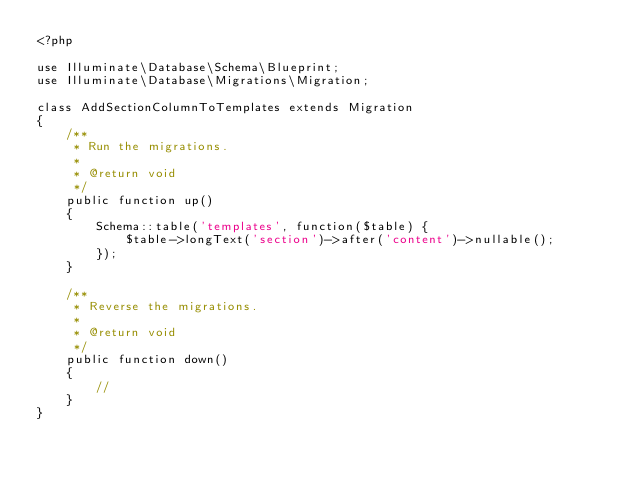<code> <loc_0><loc_0><loc_500><loc_500><_PHP_><?php

use Illuminate\Database\Schema\Blueprint;
use Illuminate\Database\Migrations\Migration;

class AddSectionColumnToTemplates extends Migration
{
    /**
     * Run the migrations.
     *
     * @return void
     */
    public function up()
    {
        Schema::table('templates', function($table) {
            $table->longText('section')->after('content')->nullable();
        });
    }

    /**
     * Reverse the migrations.
     *
     * @return void
     */
    public function down()
    {
        //
    }
}
</code> 